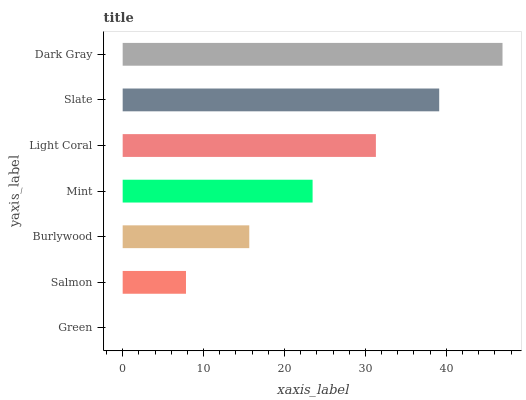Is Green the minimum?
Answer yes or no. Yes. Is Dark Gray the maximum?
Answer yes or no. Yes. Is Salmon the minimum?
Answer yes or no. No. Is Salmon the maximum?
Answer yes or no. No. Is Salmon greater than Green?
Answer yes or no. Yes. Is Green less than Salmon?
Answer yes or no. Yes. Is Green greater than Salmon?
Answer yes or no. No. Is Salmon less than Green?
Answer yes or no. No. Is Mint the high median?
Answer yes or no. Yes. Is Mint the low median?
Answer yes or no. Yes. Is Slate the high median?
Answer yes or no. No. Is Slate the low median?
Answer yes or no. No. 